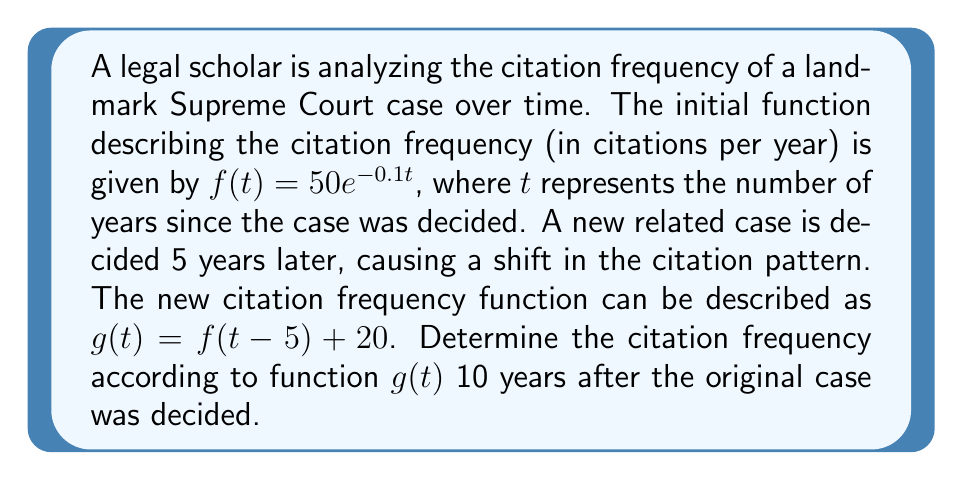Help me with this question. Let's approach this step-by-step:

1) We start with the original function $f(t) = 50e^{-0.1t}$.

2) The new function $g(t)$ is a transformation of $f(t)$:
   $g(t) = f(t-5) + 20$

3) This transformation involves two steps:
   a) A horizontal shift of 5 units to the right: $f(t-5)$
   b) A vertical shift of 20 units up: $+20$

4) To find the citation frequency 10 years after the original case:
   We need to calculate $g(10)$

5) $g(10) = f(10-5) + 20$
          $= f(5) + 20$

6) Now we calculate $f(5)$:
   $f(5) = 50e^{-0.1(5)}$
         $= 50e^{-0.5}$
         $\approx 30.33$

7) Therefore:
   $g(10) = f(5) + 20$
          $\approx 30.33 + 20$
          $\approx 50.33$
Answer: $50.33$ citations per year 